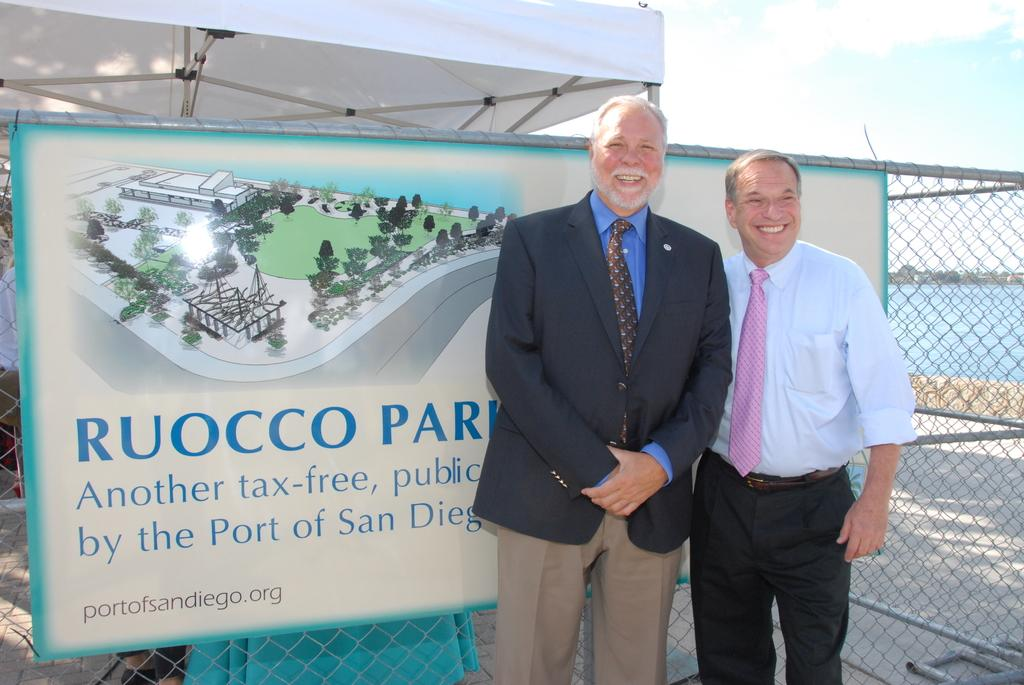How many people are in the image? There are two men in the image. What is the facial expression of the men in the image? The men are smiling. What can be seen in the background of the image? There is a banner, a fence, water, and the sky visible in the background of the image. What type of scarf is the man wearing in the image? There is no scarf visible on either man in the image. Can you describe the slope of the hill in the background of the image? There is no hill present in the image; it features a banner, a fence, water, and the sky in the background. 